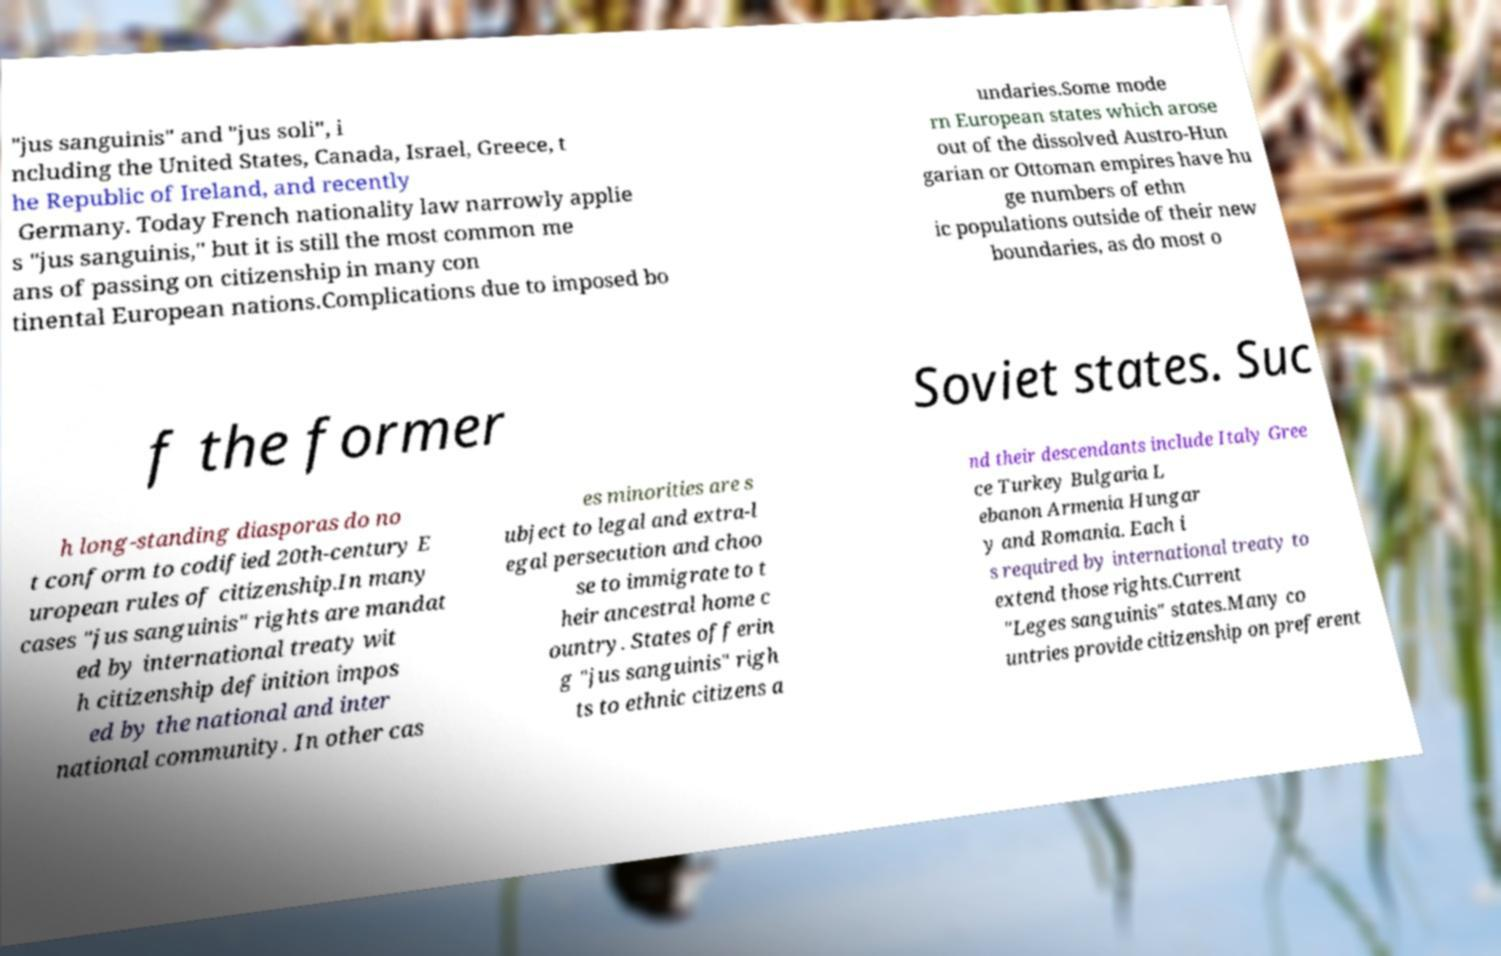Could you assist in decoding the text presented in this image and type it out clearly? "jus sanguinis" and "jus soli", i ncluding the United States, Canada, Israel, Greece, t he Republic of Ireland, and recently Germany. Today French nationality law narrowly applie s "jus sanguinis," but it is still the most common me ans of passing on citizenship in many con tinental European nations.Complications due to imposed bo undaries.Some mode rn European states which arose out of the dissolved Austro-Hun garian or Ottoman empires have hu ge numbers of ethn ic populations outside of their new boundaries, as do most o f the former Soviet states. Suc h long-standing diasporas do no t conform to codified 20th-century E uropean rules of citizenship.In many cases "jus sanguinis" rights are mandat ed by international treaty wit h citizenship definition impos ed by the national and inter national community. In other cas es minorities are s ubject to legal and extra-l egal persecution and choo se to immigrate to t heir ancestral home c ountry. States offerin g "jus sanguinis" righ ts to ethnic citizens a nd their descendants include Italy Gree ce Turkey Bulgaria L ebanon Armenia Hungar y and Romania. Each i s required by international treaty to extend those rights.Current "Leges sanguinis" states.Many co untries provide citizenship on preferent 